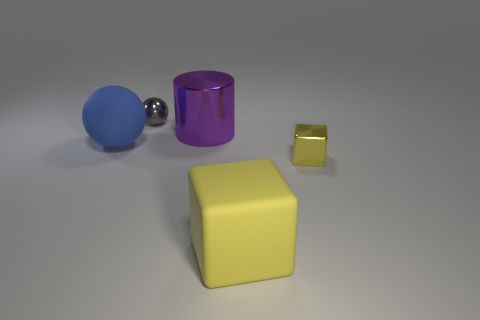Do the gray metal object and the rubber thing behind the big cube have the same size?
Your answer should be very brief. No. Is the number of tiny shiny balls to the right of the big purple metallic object less than the number of large blue matte things?
Keep it short and to the point. Yes. What material is the other thing that is the same shape as the large yellow thing?
Provide a succinct answer. Metal. What shape is the big thing that is both in front of the shiny cylinder and behind the shiny cube?
Your response must be concise. Sphere. There is a big object that is made of the same material as the large block; what shape is it?
Your answer should be compact. Sphere. What is the material of the big thing that is in front of the big rubber sphere?
Provide a succinct answer. Rubber. There is a ball that is in front of the big cylinder; does it have the same size as the rubber thing to the right of the large cylinder?
Offer a terse response. Yes. What is the color of the big metallic cylinder?
Give a very brief answer. Purple. There is a big rubber object behind the tiny yellow metallic object; is its shape the same as the large purple thing?
Make the answer very short. No. What material is the big yellow cube?
Keep it short and to the point. Rubber. 